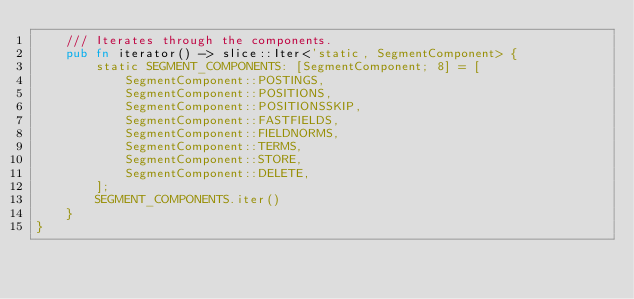<code> <loc_0><loc_0><loc_500><loc_500><_Rust_>    /// Iterates through the components.
    pub fn iterator() -> slice::Iter<'static, SegmentComponent> {
        static SEGMENT_COMPONENTS: [SegmentComponent; 8] = [
            SegmentComponent::POSTINGS,
            SegmentComponent::POSITIONS,
            SegmentComponent::POSITIONSSKIP,
            SegmentComponent::FASTFIELDS,
            SegmentComponent::FIELDNORMS,
            SegmentComponent::TERMS,
            SegmentComponent::STORE,
            SegmentComponent::DELETE,
        ];
        SEGMENT_COMPONENTS.iter()
    }
}
</code> 